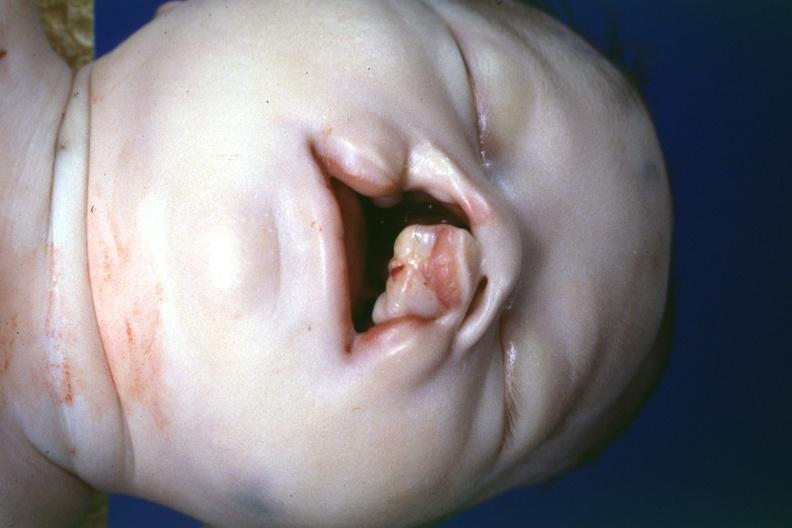what does this image show?
Answer the question using a single word or phrase. Left side lesion 